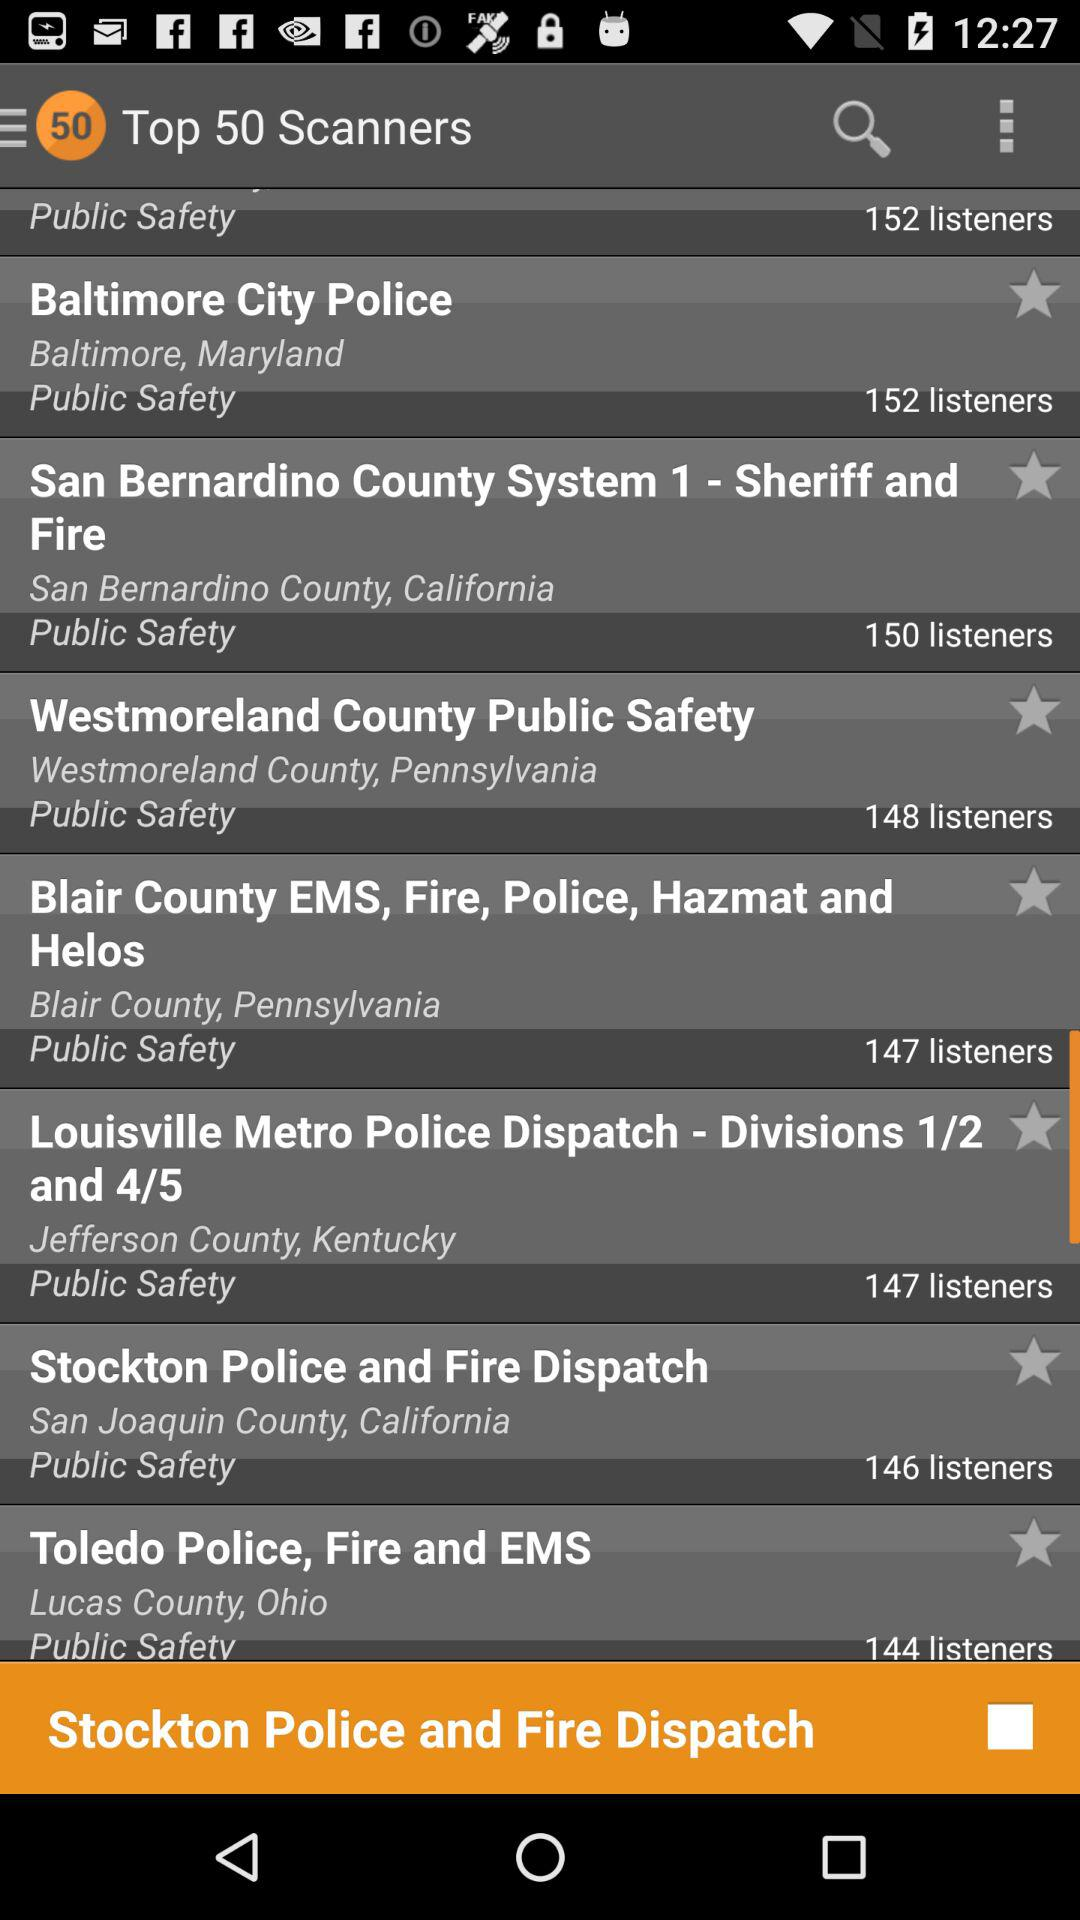Where is the "Baltimore City Police" located? It is located in Baltimore, Maryland. 